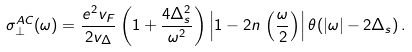<formula> <loc_0><loc_0><loc_500><loc_500>\sigma _ { \perp } ^ { A C } ( \omega ) = \frac { e ^ { 2 } v _ { F } } { 2 v _ { \Delta } } \left ( 1 + \frac { 4 \Delta _ { s } ^ { 2 } } { \omega ^ { 2 } } \right ) \left | 1 - 2 n \, \left ( \frac { \omega } { 2 } \right ) \right | \theta ( | \omega | - 2 \Delta _ { s } ) \, .</formula> 